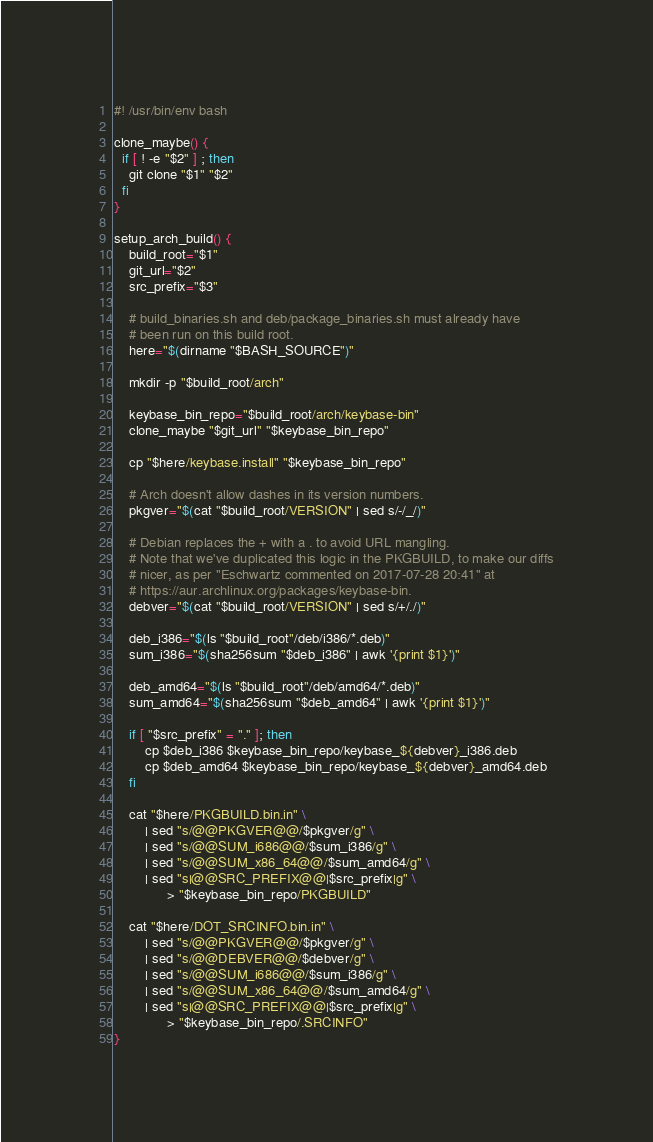Convert code to text. <code><loc_0><loc_0><loc_500><loc_500><_Bash_>#! /usr/bin/env bash

clone_maybe() {
  if [ ! -e "$2" ] ; then
    git clone "$1" "$2"
  fi
}

setup_arch_build() {
    build_root="$1"
    git_url="$2"
    src_prefix="$3"

    # build_binaries.sh and deb/package_binaries.sh must already have
    # been run on this build root.
    here="$(dirname "$BASH_SOURCE")"

    mkdir -p "$build_root/arch"

    keybase_bin_repo="$build_root/arch/keybase-bin"
    clone_maybe "$git_url" "$keybase_bin_repo"

    cp "$here/keybase.install" "$keybase_bin_repo"

    # Arch doesn't allow dashes in its version numbers.
    pkgver="$(cat "$build_root/VERSION" | sed s/-/_/)"

    # Debian replaces the + with a . to avoid URL mangling.
    # Note that we've duplicated this logic in the PKGBUILD, to make our diffs
    # nicer, as per "Eschwartz commented on 2017-07-28 20:41" at
    # https://aur.archlinux.org/packages/keybase-bin.
    debver="$(cat "$build_root/VERSION" | sed s/+/./)"

    deb_i386="$(ls "$build_root"/deb/i386/*.deb)"
    sum_i386="$(sha256sum "$deb_i386" | awk '{print $1}')"

    deb_amd64="$(ls "$build_root"/deb/amd64/*.deb)"
    sum_amd64="$(sha256sum "$deb_amd64" | awk '{print $1}')"

    if [ "$src_prefix" = "." ]; then
        cp $deb_i386 $keybase_bin_repo/keybase_${debver}_i386.deb
        cp $deb_amd64 $keybase_bin_repo/keybase_${debver}_amd64.deb
    fi

    cat "$here/PKGBUILD.bin.in" \
        | sed "s/@@PKGVER@@/$pkgver/g" \
        | sed "s/@@SUM_i686@@/$sum_i386/g" \
        | sed "s/@@SUM_x86_64@@/$sum_amd64/g" \
        | sed "s|@@SRC_PREFIX@@|$src_prefix|g" \
              > "$keybase_bin_repo/PKGBUILD"

    cat "$here/DOT_SRCINFO.bin.in" \
        | sed "s/@@PKGVER@@/$pkgver/g" \
        | sed "s/@@DEBVER@@/$debver/g" \
        | sed "s/@@SUM_i686@@/$sum_i386/g" \
        | sed "s/@@SUM_x86_64@@/$sum_amd64/g" \
        | sed "s|@@SRC_PREFIX@@|$src_prefix|g" \
              > "$keybase_bin_repo/.SRCINFO"
}
</code> 